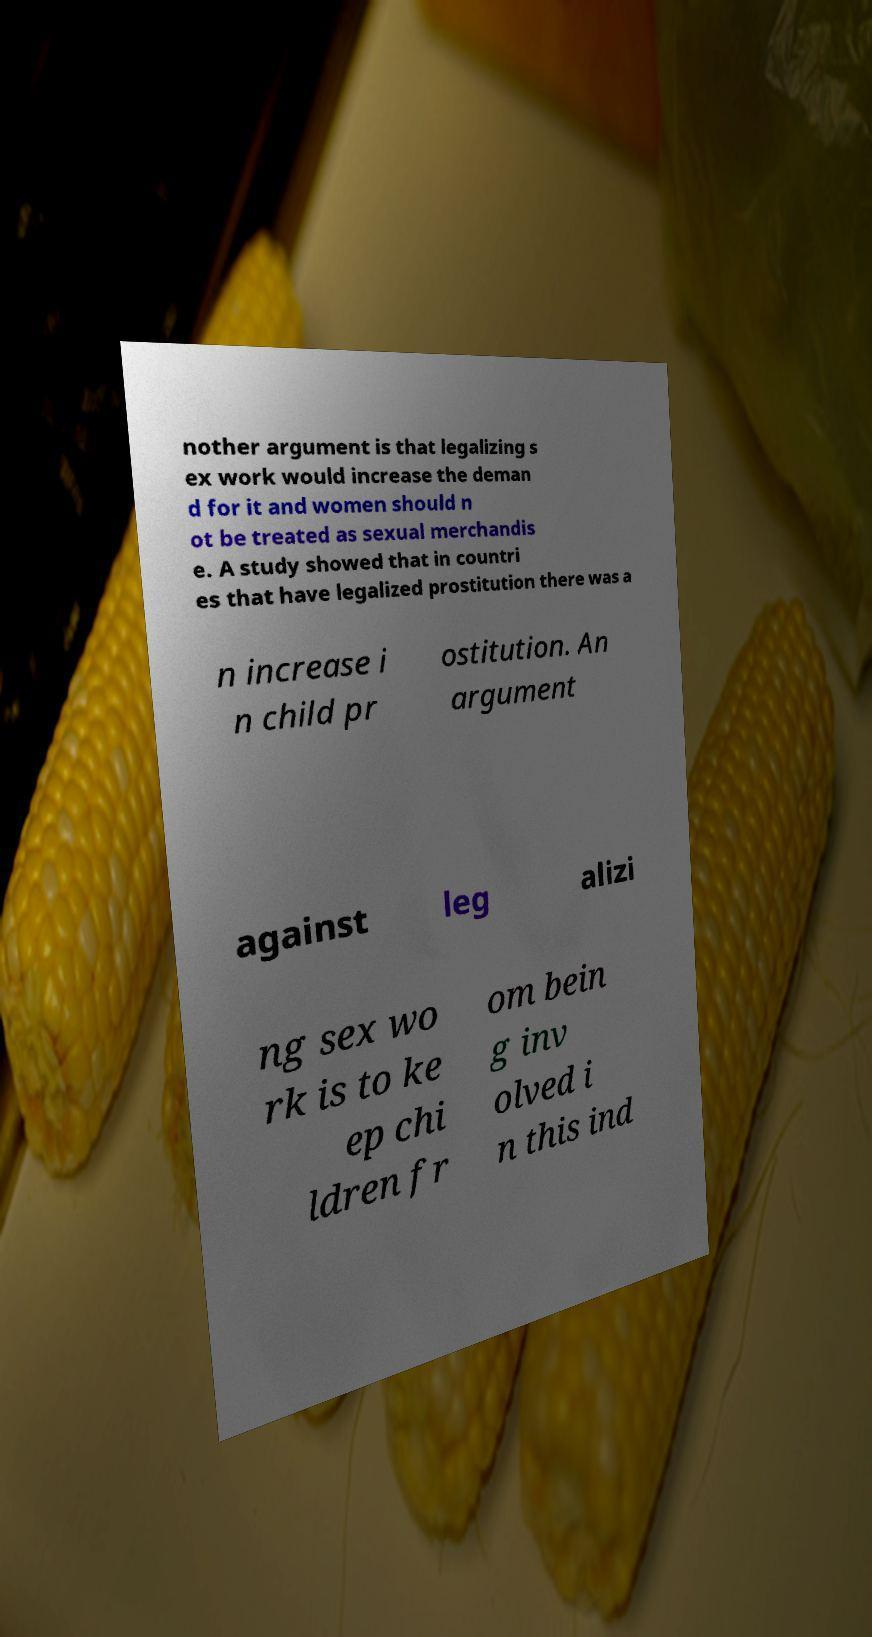What messages or text are displayed in this image? I need them in a readable, typed format. nother argument is that legalizing s ex work would increase the deman d for it and women should n ot be treated as sexual merchandis e. A study showed that in countri es that have legalized prostitution there was a n increase i n child pr ostitution. An argument against leg alizi ng sex wo rk is to ke ep chi ldren fr om bein g inv olved i n this ind 